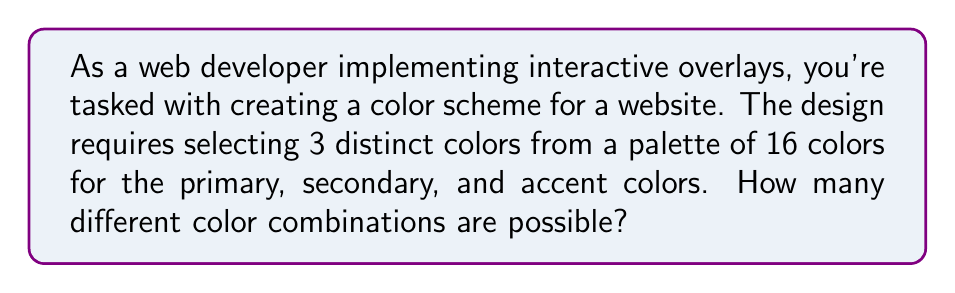Could you help me with this problem? Let's approach this step-by-step:

1) We are selecting 3 distinct colors from 16 available colors.

2) The order of selection matters because each color has a specific role (primary, secondary, accent).

3) This scenario is a permutation problem, specifically a permutation without repetition.

4) The formula for permutations without repetition is:

   $$P(n,r) = \frac{n!}{(n-r)!}$$

   Where $n$ is the total number of items to choose from, and $r$ is the number of items being chosen.

5) In this case, $n = 16$ (total colors) and $r = 3$ (colors we're selecting).

6) Plugging these values into our formula:

   $$P(16,3) = \frac{16!}{(16-3)!} = \frac{16!}{13!}$$

7) Expanding this:
   
   $$\frac{16 * 15 * 14 * 13!}{13!}$$

8) The $13!$ cancels out in the numerator and denominator:

   $$16 * 15 * 14 = 3360$$

Therefore, there are 3360 possible color combinations for the website's color scheme.
Answer: 3360 